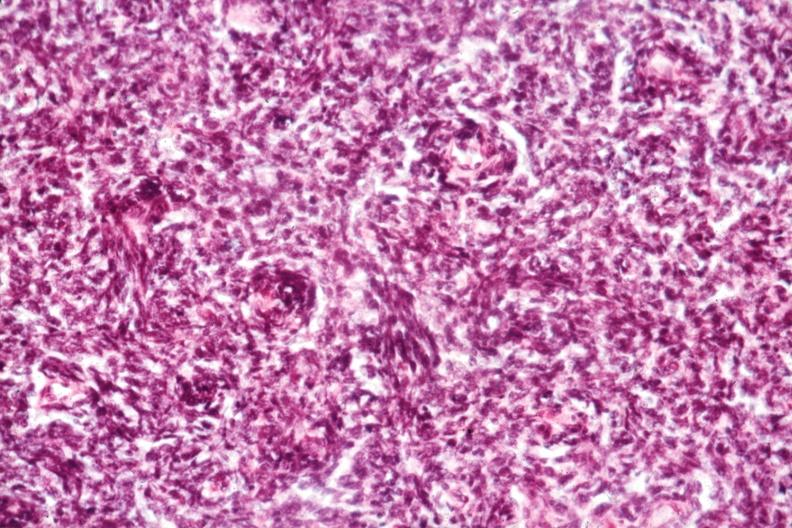s hematologic present?
Answer the question using a single word or phrase. Yes 